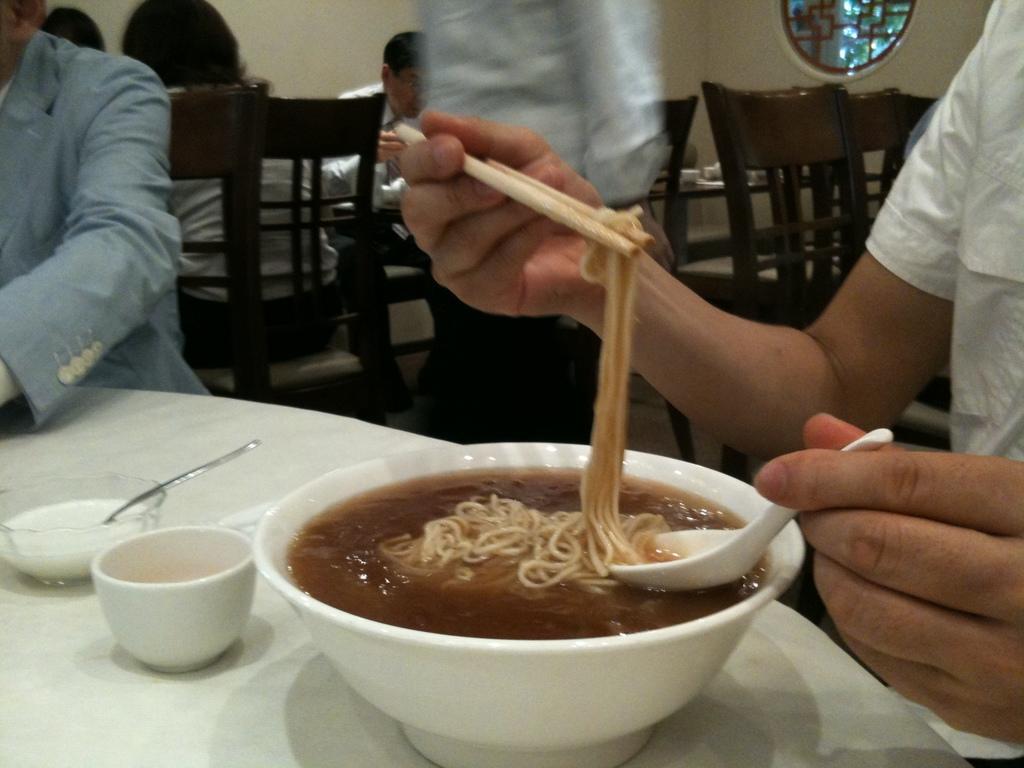Please provide a concise description of this image. In this picture there is a man who is wearing white shirt and holding chopstick and spoon. On the left there is another man is wearing suit. Both of them are sitting near to the table. On the table we can see cups, spoon, noodles and soup. In the background we can see the group of persons were sitting on the chair. At the top there is a man who is standing near to them. On the top right corner there is a window. Through the window we can see the trees. 